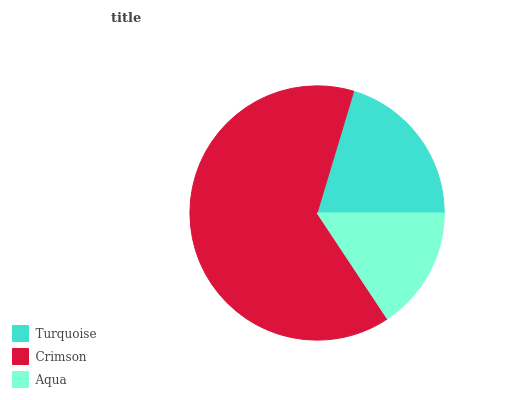Is Aqua the minimum?
Answer yes or no. Yes. Is Crimson the maximum?
Answer yes or no. Yes. Is Crimson the minimum?
Answer yes or no. No. Is Aqua the maximum?
Answer yes or no. No. Is Crimson greater than Aqua?
Answer yes or no. Yes. Is Aqua less than Crimson?
Answer yes or no. Yes. Is Aqua greater than Crimson?
Answer yes or no. No. Is Crimson less than Aqua?
Answer yes or no. No. Is Turquoise the high median?
Answer yes or no. Yes. Is Turquoise the low median?
Answer yes or no. Yes. Is Aqua the high median?
Answer yes or no. No. Is Aqua the low median?
Answer yes or no. No. 